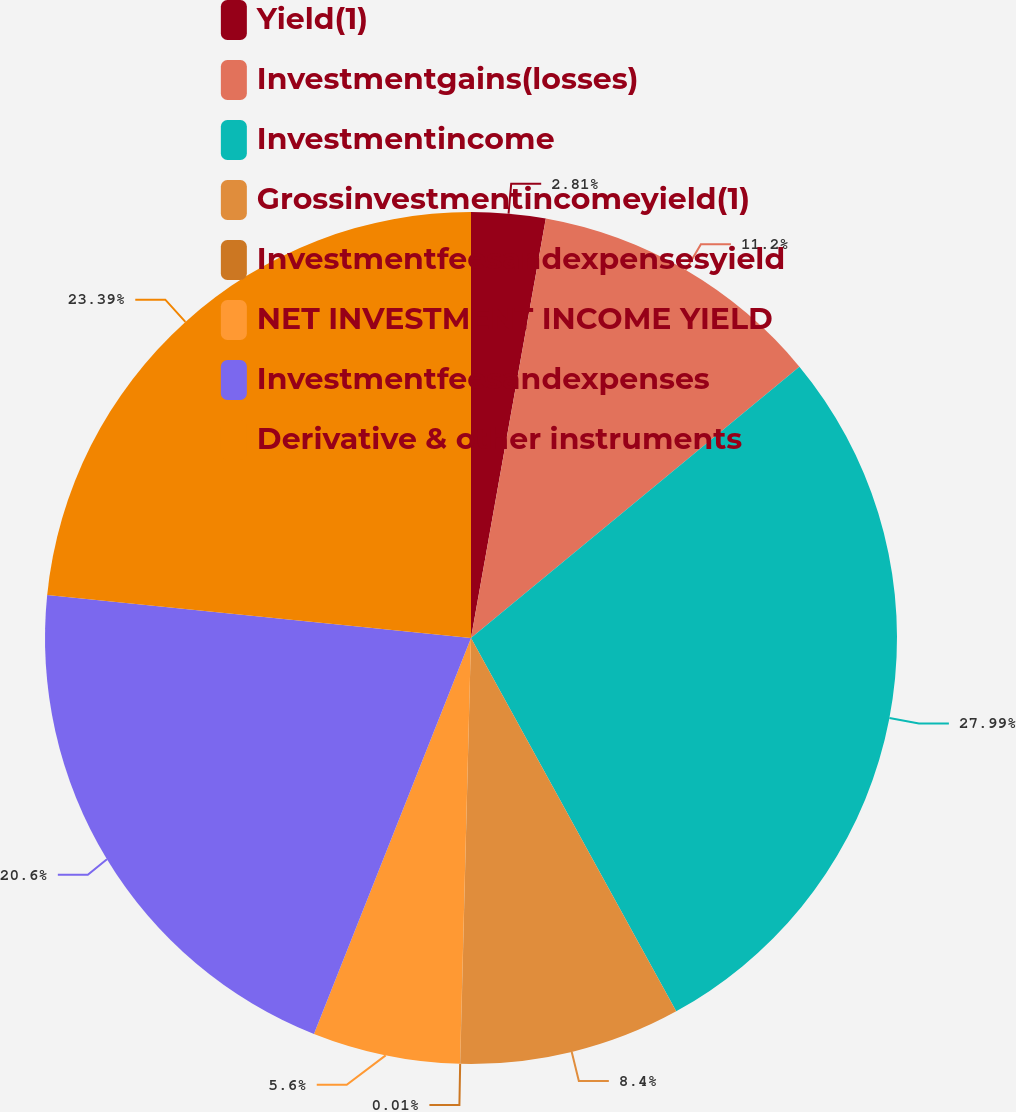Convert chart. <chart><loc_0><loc_0><loc_500><loc_500><pie_chart><fcel>Yield(1)<fcel>Investmentgains(losses)<fcel>Investmentincome<fcel>Grossinvestmentincomeyield(1)<fcel>Investmentfeesandexpensesyield<fcel>NET INVESTMENT INCOME YIELD<fcel>Investmentfeesandexpenses<fcel>Derivative & other instruments<nl><fcel>2.81%<fcel>11.2%<fcel>27.99%<fcel>8.4%<fcel>0.01%<fcel>5.6%<fcel>20.6%<fcel>23.39%<nl></chart> 